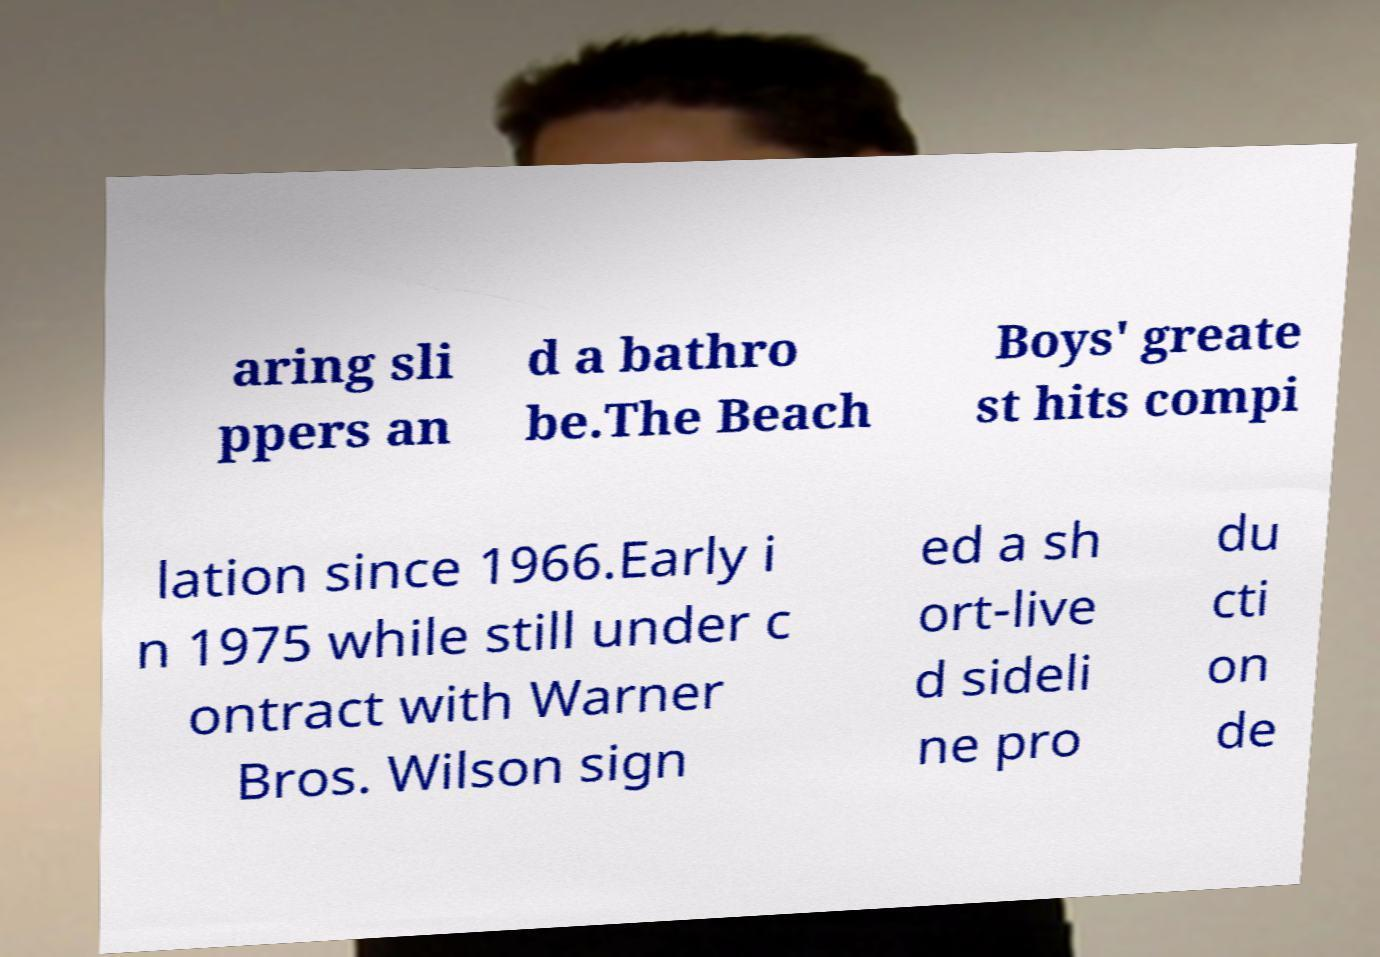Please identify and transcribe the text found in this image. aring sli ppers an d a bathro be.The Beach Boys' greate st hits compi lation since 1966.Early i n 1975 while still under c ontract with Warner Bros. Wilson sign ed a sh ort-live d sideli ne pro du cti on de 